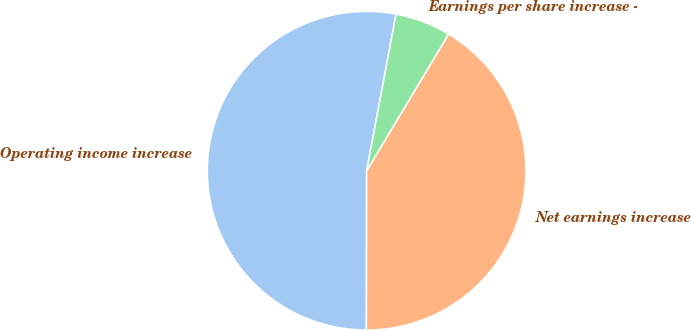Convert chart to OTSL. <chart><loc_0><loc_0><loc_500><loc_500><pie_chart><fcel>Operating income increase<fcel>Net earnings increase<fcel>Earnings per share increase -<nl><fcel>52.93%<fcel>41.43%<fcel>5.64%<nl></chart> 